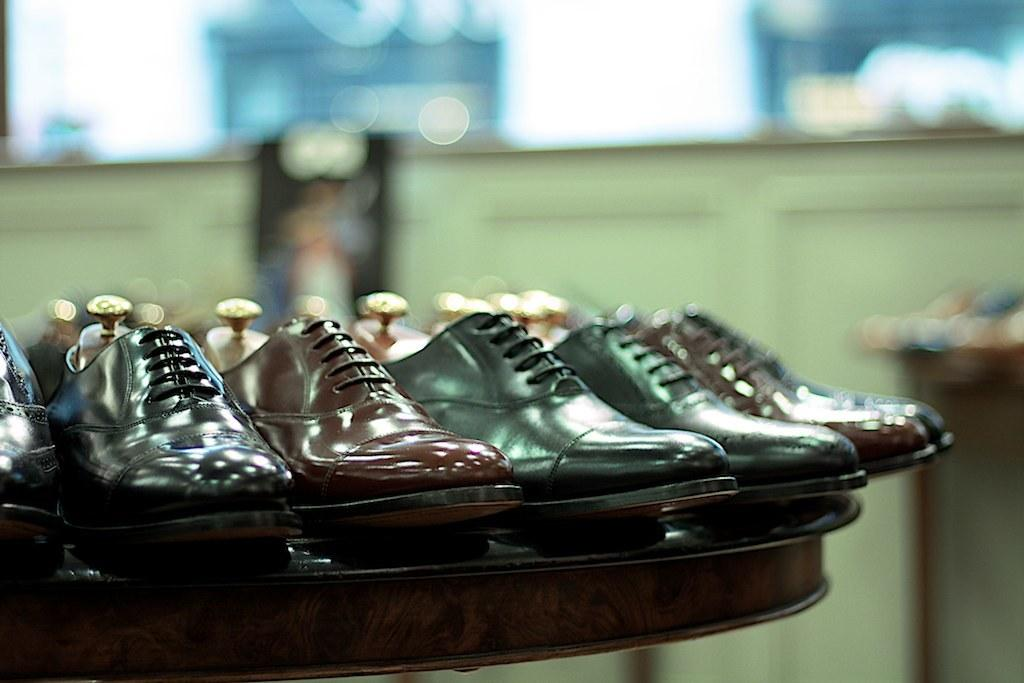What objects are placed on the table in the image? There are shoes on the table in the image. Can you describe the background of the image? The background of the image is blurry. How many friends are sitting on the beam in the image? There is no beam or friends present in the image. 